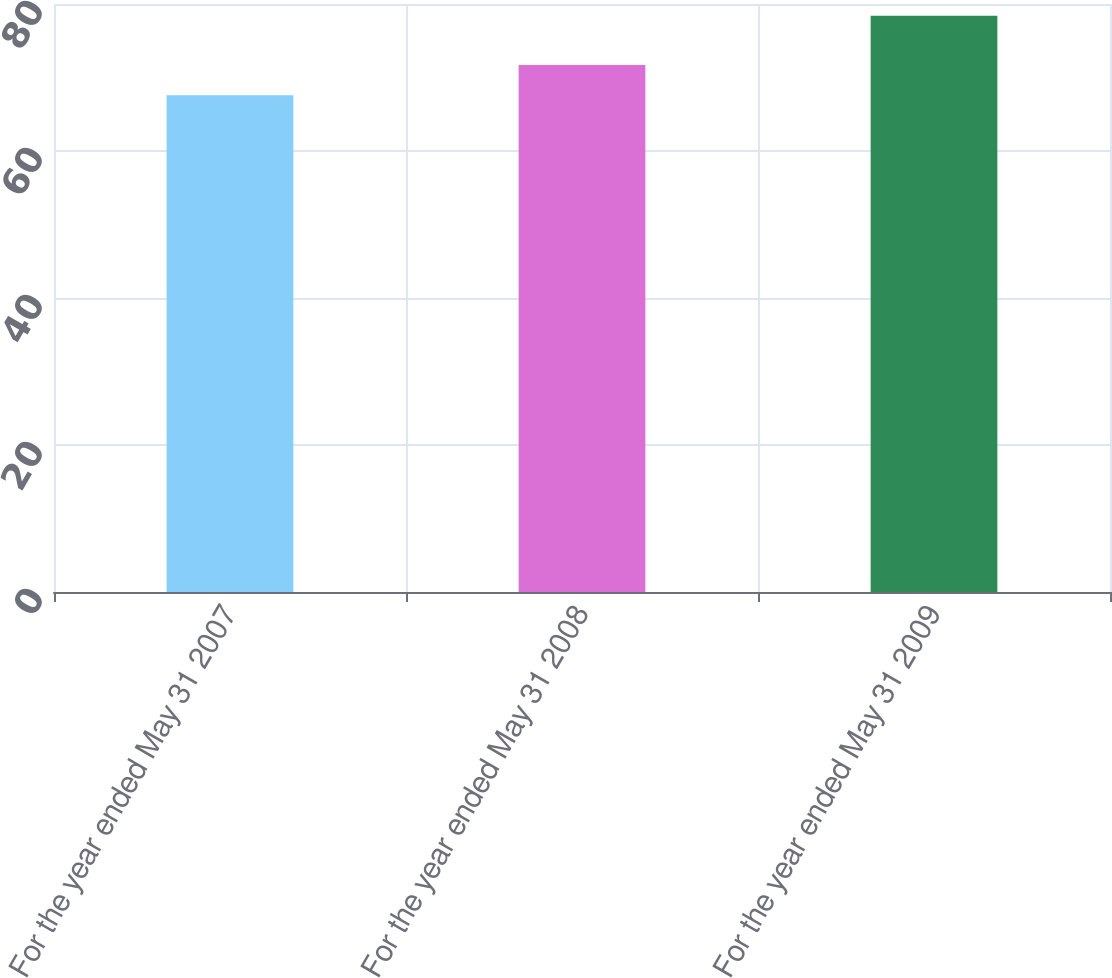<chart> <loc_0><loc_0><loc_500><loc_500><bar_chart><fcel>For the year ended May 31 2007<fcel>For the year ended May 31 2008<fcel>For the year ended May 31 2009<nl><fcel>67.6<fcel>71.7<fcel>78.4<nl></chart> 